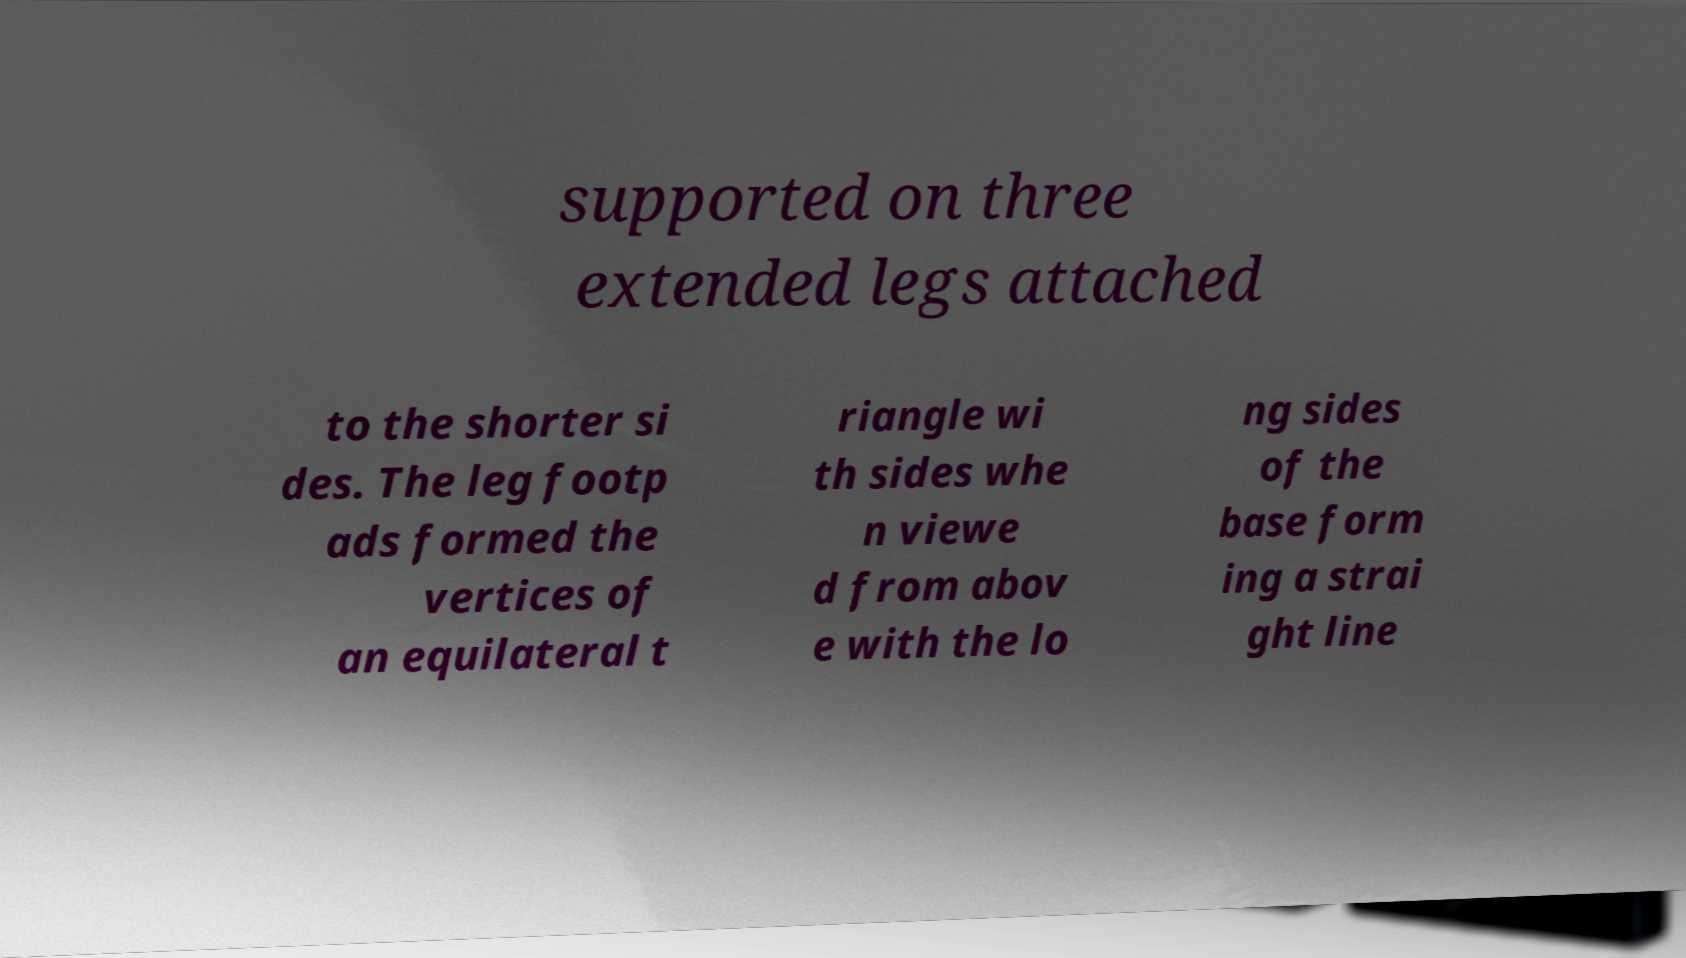Could you assist in decoding the text presented in this image and type it out clearly? supported on three extended legs attached to the shorter si des. The leg footp ads formed the vertices of an equilateral t riangle wi th sides whe n viewe d from abov e with the lo ng sides of the base form ing a strai ght line 